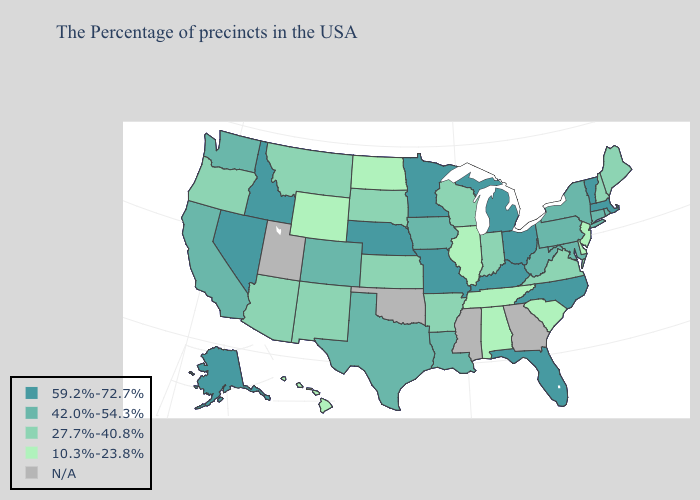Which states have the highest value in the USA?
Write a very short answer. Massachusetts, Vermont, North Carolina, Ohio, Florida, Michigan, Kentucky, Missouri, Minnesota, Nebraska, Idaho, Nevada, Alaska. What is the lowest value in states that border Illinois?
Give a very brief answer. 27.7%-40.8%. Does Alabama have the lowest value in the South?
Concise answer only. Yes. Which states have the lowest value in the USA?
Answer briefly. New Jersey, Delaware, South Carolina, Alabama, Tennessee, Illinois, North Dakota, Wyoming, Hawaii. Name the states that have a value in the range 42.0%-54.3%?
Keep it brief. Rhode Island, Connecticut, New York, Maryland, Pennsylvania, West Virginia, Louisiana, Iowa, Texas, Colorado, California, Washington. Among the states that border Connecticut , does Rhode Island have the highest value?
Keep it brief. No. Does New Jersey have the lowest value in the USA?
Write a very short answer. Yes. Among the states that border Wisconsin , does Minnesota have the highest value?
Quick response, please. Yes. Which states have the lowest value in the Northeast?
Quick response, please. New Jersey. What is the value of Texas?
Give a very brief answer. 42.0%-54.3%. Among the states that border Ohio , does Indiana have the lowest value?
Be succinct. Yes. Among the states that border North Carolina , does South Carolina have the highest value?
Be succinct. No. Which states hav the highest value in the South?
Short answer required. North Carolina, Florida, Kentucky. What is the highest value in the MidWest ?
Be succinct. 59.2%-72.7%. 